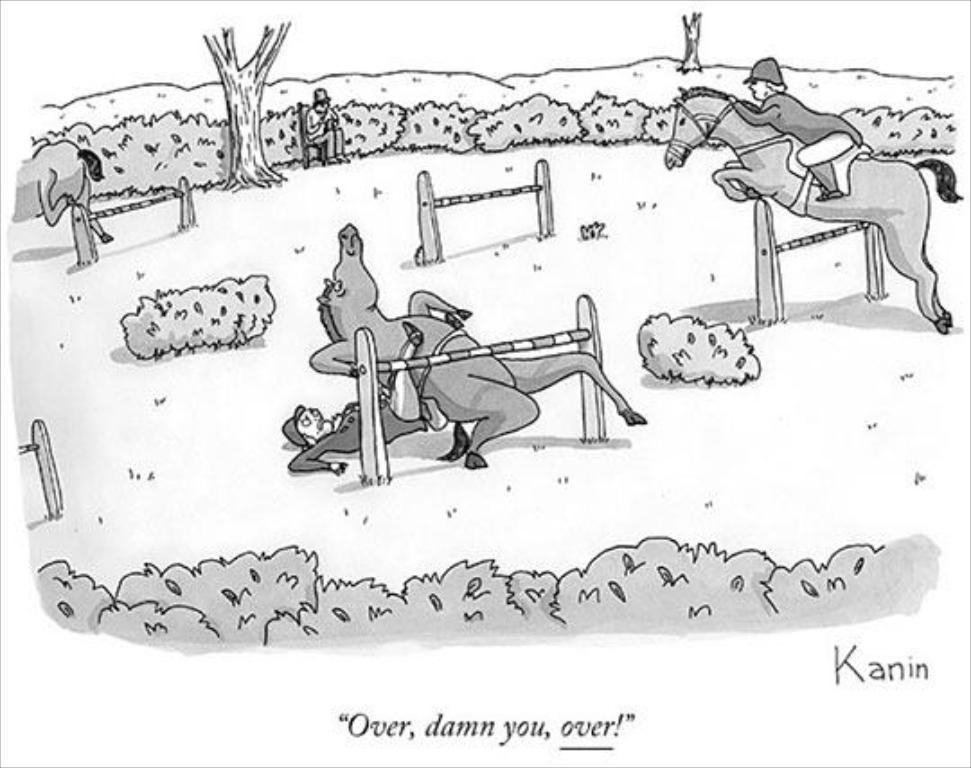How would you summarize this image in a sentence or two? This picture is a sketch. In this image we can see some animals, persons, trees, plants, ground are there. At the bottom of the image some text is there. 